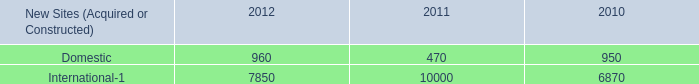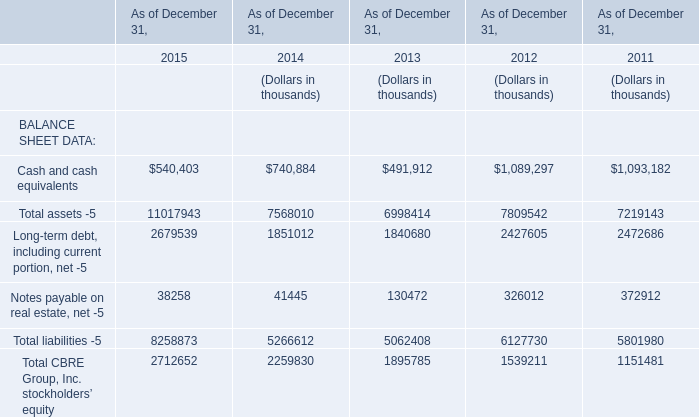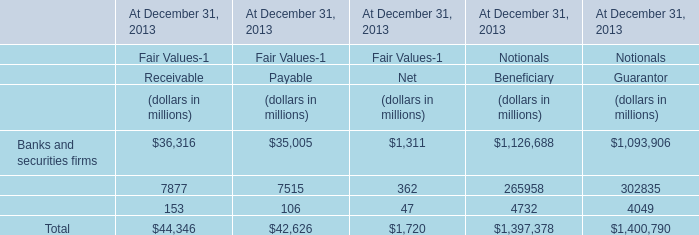What is the proportion of Cash and cash equivalents to the total in 2015 ? 
Computations: (540403 / 2712652)
Answer: 0.19922. 